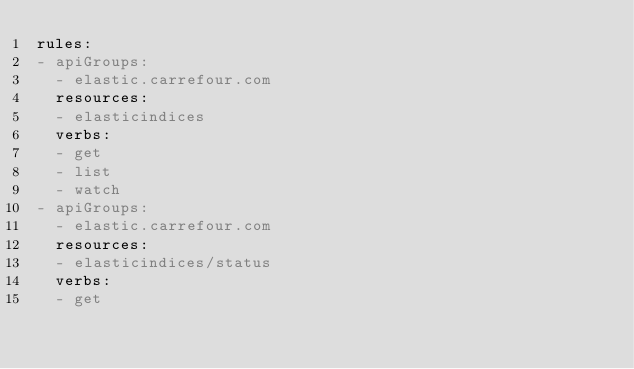<code> <loc_0><loc_0><loc_500><loc_500><_YAML_>rules:
- apiGroups:
  - elastic.carrefour.com
  resources:
  - elasticindices
  verbs:
  - get
  - list
  - watch
- apiGroups:
  - elastic.carrefour.com
  resources:
  - elasticindices/status
  verbs:
  - get
</code> 